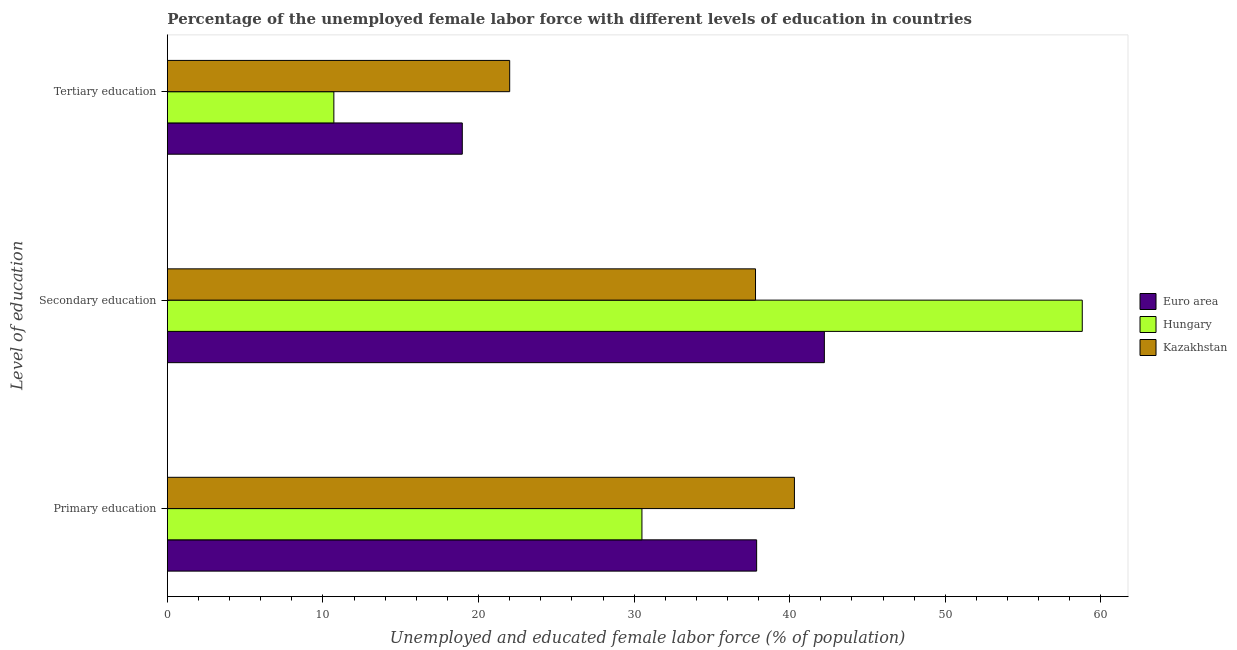How many different coloured bars are there?
Your answer should be compact. 3. How many bars are there on the 3rd tick from the top?
Your answer should be compact. 3. How many bars are there on the 2nd tick from the bottom?
Your response must be concise. 3. What is the label of the 2nd group of bars from the top?
Ensure brevity in your answer.  Secondary education. What is the percentage of female labor force who received primary education in Hungary?
Your answer should be very brief. 30.5. Across all countries, what is the maximum percentage of female labor force who received secondary education?
Provide a succinct answer. 58.8. Across all countries, what is the minimum percentage of female labor force who received tertiary education?
Offer a terse response. 10.7. In which country was the percentage of female labor force who received tertiary education maximum?
Offer a very short reply. Kazakhstan. In which country was the percentage of female labor force who received tertiary education minimum?
Your answer should be compact. Hungary. What is the total percentage of female labor force who received primary education in the graph?
Offer a terse response. 108.67. What is the difference between the percentage of female labor force who received secondary education in Euro area and that in Hungary?
Ensure brevity in your answer.  -16.58. What is the difference between the percentage of female labor force who received secondary education in Hungary and the percentage of female labor force who received tertiary education in Kazakhstan?
Ensure brevity in your answer.  36.8. What is the average percentage of female labor force who received secondary education per country?
Offer a terse response. 46.27. What is the difference between the percentage of female labor force who received primary education and percentage of female labor force who received secondary education in Euro area?
Offer a very short reply. -4.35. In how many countries, is the percentage of female labor force who received primary education greater than 30 %?
Keep it short and to the point. 3. What is the ratio of the percentage of female labor force who received tertiary education in Hungary to that in Euro area?
Provide a short and direct response. 0.56. Is the percentage of female labor force who received tertiary education in Kazakhstan less than that in Euro area?
Your answer should be compact. No. Is the difference between the percentage of female labor force who received secondary education in Kazakhstan and Hungary greater than the difference between the percentage of female labor force who received tertiary education in Kazakhstan and Hungary?
Ensure brevity in your answer.  No. What is the difference between the highest and the second highest percentage of female labor force who received secondary education?
Make the answer very short. 16.58. What is the difference between the highest and the lowest percentage of female labor force who received tertiary education?
Your answer should be compact. 11.3. In how many countries, is the percentage of female labor force who received tertiary education greater than the average percentage of female labor force who received tertiary education taken over all countries?
Your answer should be very brief. 2. Is the sum of the percentage of female labor force who received secondary education in Hungary and Euro area greater than the maximum percentage of female labor force who received tertiary education across all countries?
Give a very brief answer. Yes. What does the 2nd bar from the top in Secondary education represents?
Your answer should be very brief. Hungary. What does the 2nd bar from the bottom in Tertiary education represents?
Give a very brief answer. Hungary. Is it the case that in every country, the sum of the percentage of female labor force who received primary education and percentage of female labor force who received secondary education is greater than the percentage of female labor force who received tertiary education?
Your response must be concise. Yes. Are all the bars in the graph horizontal?
Make the answer very short. Yes. How many countries are there in the graph?
Your answer should be compact. 3. Are the values on the major ticks of X-axis written in scientific E-notation?
Give a very brief answer. No. What is the title of the graph?
Offer a terse response. Percentage of the unemployed female labor force with different levels of education in countries. Does "Suriname" appear as one of the legend labels in the graph?
Ensure brevity in your answer.  No. What is the label or title of the X-axis?
Your response must be concise. Unemployed and educated female labor force (% of population). What is the label or title of the Y-axis?
Ensure brevity in your answer.  Level of education. What is the Unemployed and educated female labor force (% of population) in Euro area in Primary education?
Provide a succinct answer. 37.87. What is the Unemployed and educated female labor force (% of population) of Hungary in Primary education?
Keep it short and to the point. 30.5. What is the Unemployed and educated female labor force (% of population) of Kazakhstan in Primary education?
Ensure brevity in your answer.  40.3. What is the Unemployed and educated female labor force (% of population) of Euro area in Secondary education?
Offer a terse response. 42.22. What is the Unemployed and educated female labor force (% of population) in Hungary in Secondary education?
Ensure brevity in your answer.  58.8. What is the Unemployed and educated female labor force (% of population) in Kazakhstan in Secondary education?
Your answer should be compact. 37.8. What is the Unemployed and educated female labor force (% of population) of Euro area in Tertiary education?
Your answer should be compact. 18.95. What is the Unemployed and educated female labor force (% of population) in Hungary in Tertiary education?
Your answer should be compact. 10.7. Across all Level of education, what is the maximum Unemployed and educated female labor force (% of population) of Euro area?
Provide a succinct answer. 42.22. Across all Level of education, what is the maximum Unemployed and educated female labor force (% of population) of Hungary?
Provide a short and direct response. 58.8. Across all Level of education, what is the maximum Unemployed and educated female labor force (% of population) in Kazakhstan?
Keep it short and to the point. 40.3. Across all Level of education, what is the minimum Unemployed and educated female labor force (% of population) in Euro area?
Provide a succinct answer. 18.95. Across all Level of education, what is the minimum Unemployed and educated female labor force (% of population) of Hungary?
Offer a terse response. 10.7. Across all Level of education, what is the minimum Unemployed and educated female labor force (% of population) of Kazakhstan?
Make the answer very short. 22. What is the total Unemployed and educated female labor force (% of population) in Euro area in the graph?
Ensure brevity in your answer.  99.05. What is the total Unemployed and educated female labor force (% of population) of Hungary in the graph?
Your answer should be very brief. 100. What is the total Unemployed and educated female labor force (% of population) of Kazakhstan in the graph?
Your response must be concise. 100.1. What is the difference between the Unemployed and educated female labor force (% of population) in Euro area in Primary education and that in Secondary education?
Make the answer very short. -4.35. What is the difference between the Unemployed and educated female labor force (% of population) of Hungary in Primary education and that in Secondary education?
Your answer should be compact. -28.3. What is the difference between the Unemployed and educated female labor force (% of population) in Kazakhstan in Primary education and that in Secondary education?
Provide a succinct answer. 2.5. What is the difference between the Unemployed and educated female labor force (% of population) of Euro area in Primary education and that in Tertiary education?
Offer a terse response. 18.92. What is the difference between the Unemployed and educated female labor force (% of population) of Hungary in Primary education and that in Tertiary education?
Keep it short and to the point. 19.8. What is the difference between the Unemployed and educated female labor force (% of population) in Euro area in Secondary education and that in Tertiary education?
Ensure brevity in your answer.  23.27. What is the difference between the Unemployed and educated female labor force (% of population) of Hungary in Secondary education and that in Tertiary education?
Keep it short and to the point. 48.1. What is the difference between the Unemployed and educated female labor force (% of population) in Euro area in Primary education and the Unemployed and educated female labor force (% of population) in Hungary in Secondary education?
Offer a terse response. -20.93. What is the difference between the Unemployed and educated female labor force (% of population) of Euro area in Primary education and the Unemployed and educated female labor force (% of population) of Kazakhstan in Secondary education?
Provide a short and direct response. 0.07. What is the difference between the Unemployed and educated female labor force (% of population) of Euro area in Primary education and the Unemployed and educated female labor force (% of population) of Hungary in Tertiary education?
Your response must be concise. 27.17. What is the difference between the Unemployed and educated female labor force (% of population) in Euro area in Primary education and the Unemployed and educated female labor force (% of population) in Kazakhstan in Tertiary education?
Keep it short and to the point. 15.87. What is the difference between the Unemployed and educated female labor force (% of population) of Euro area in Secondary education and the Unemployed and educated female labor force (% of population) of Hungary in Tertiary education?
Your answer should be compact. 31.52. What is the difference between the Unemployed and educated female labor force (% of population) in Euro area in Secondary education and the Unemployed and educated female labor force (% of population) in Kazakhstan in Tertiary education?
Offer a terse response. 20.22. What is the difference between the Unemployed and educated female labor force (% of population) of Hungary in Secondary education and the Unemployed and educated female labor force (% of population) of Kazakhstan in Tertiary education?
Offer a terse response. 36.8. What is the average Unemployed and educated female labor force (% of population) in Euro area per Level of education?
Give a very brief answer. 33.02. What is the average Unemployed and educated female labor force (% of population) of Hungary per Level of education?
Make the answer very short. 33.33. What is the average Unemployed and educated female labor force (% of population) in Kazakhstan per Level of education?
Keep it short and to the point. 33.37. What is the difference between the Unemployed and educated female labor force (% of population) in Euro area and Unemployed and educated female labor force (% of population) in Hungary in Primary education?
Your response must be concise. 7.37. What is the difference between the Unemployed and educated female labor force (% of population) of Euro area and Unemployed and educated female labor force (% of population) of Kazakhstan in Primary education?
Give a very brief answer. -2.43. What is the difference between the Unemployed and educated female labor force (% of population) in Euro area and Unemployed and educated female labor force (% of population) in Hungary in Secondary education?
Your answer should be compact. -16.58. What is the difference between the Unemployed and educated female labor force (% of population) in Euro area and Unemployed and educated female labor force (% of population) in Kazakhstan in Secondary education?
Make the answer very short. 4.42. What is the difference between the Unemployed and educated female labor force (% of population) of Euro area and Unemployed and educated female labor force (% of population) of Hungary in Tertiary education?
Your answer should be compact. 8.25. What is the difference between the Unemployed and educated female labor force (% of population) in Euro area and Unemployed and educated female labor force (% of population) in Kazakhstan in Tertiary education?
Provide a succinct answer. -3.05. What is the difference between the Unemployed and educated female labor force (% of population) of Hungary and Unemployed and educated female labor force (% of population) of Kazakhstan in Tertiary education?
Keep it short and to the point. -11.3. What is the ratio of the Unemployed and educated female labor force (% of population) in Euro area in Primary education to that in Secondary education?
Offer a terse response. 0.9. What is the ratio of the Unemployed and educated female labor force (% of population) of Hungary in Primary education to that in Secondary education?
Your response must be concise. 0.52. What is the ratio of the Unemployed and educated female labor force (% of population) of Kazakhstan in Primary education to that in Secondary education?
Give a very brief answer. 1.07. What is the ratio of the Unemployed and educated female labor force (% of population) in Euro area in Primary education to that in Tertiary education?
Your answer should be compact. 2. What is the ratio of the Unemployed and educated female labor force (% of population) of Hungary in Primary education to that in Tertiary education?
Provide a succinct answer. 2.85. What is the ratio of the Unemployed and educated female labor force (% of population) in Kazakhstan in Primary education to that in Tertiary education?
Provide a succinct answer. 1.83. What is the ratio of the Unemployed and educated female labor force (% of population) of Euro area in Secondary education to that in Tertiary education?
Offer a very short reply. 2.23. What is the ratio of the Unemployed and educated female labor force (% of population) of Hungary in Secondary education to that in Tertiary education?
Provide a short and direct response. 5.5. What is the ratio of the Unemployed and educated female labor force (% of population) in Kazakhstan in Secondary education to that in Tertiary education?
Keep it short and to the point. 1.72. What is the difference between the highest and the second highest Unemployed and educated female labor force (% of population) of Euro area?
Make the answer very short. 4.35. What is the difference between the highest and the second highest Unemployed and educated female labor force (% of population) in Hungary?
Give a very brief answer. 28.3. What is the difference between the highest and the second highest Unemployed and educated female labor force (% of population) in Kazakhstan?
Offer a very short reply. 2.5. What is the difference between the highest and the lowest Unemployed and educated female labor force (% of population) in Euro area?
Your answer should be compact. 23.27. What is the difference between the highest and the lowest Unemployed and educated female labor force (% of population) in Hungary?
Give a very brief answer. 48.1. 